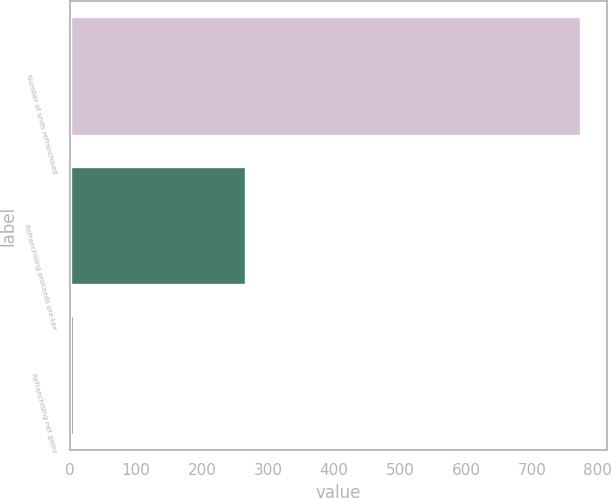Convert chart to OTSL. <chart><loc_0><loc_0><loc_500><loc_500><bar_chart><fcel>Number of units refranchised<fcel>Refranchising proceeds pre-tax<fcel>Refranchising net gains<nl><fcel>775<fcel>266<fcel>5<nl></chart> 